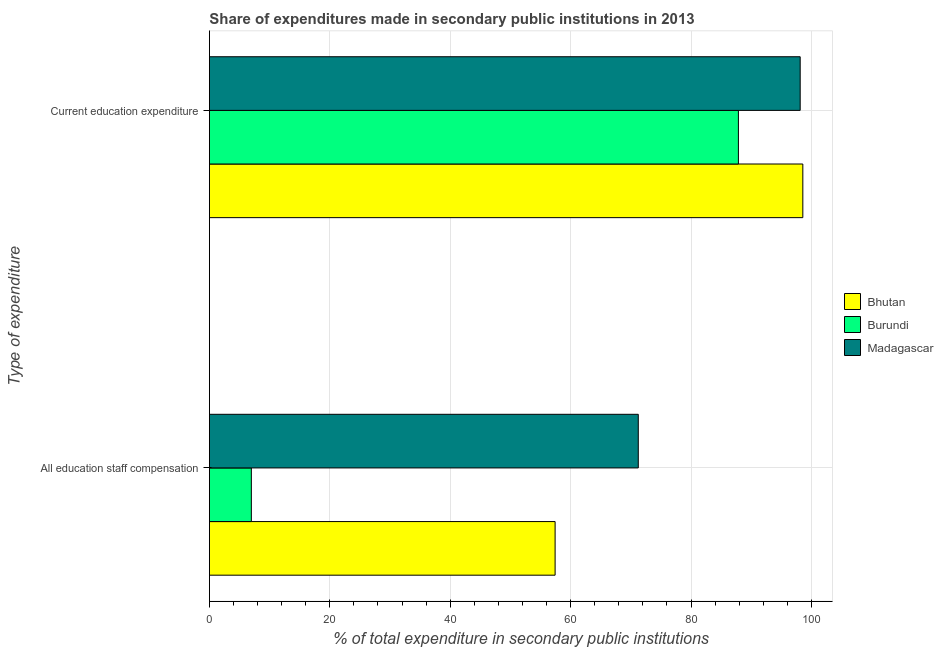How many different coloured bars are there?
Your answer should be very brief. 3. Are the number of bars on each tick of the Y-axis equal?
Give a very brief answer. Yes. What is the label of the 1st group of bars from the top?
Provide a short and direct response. Current education expenditure. What is the expenditure in staff compensation in Burundi?
Provide a short and direct response. 6.97. Across all countries, what is the maximum expenditure in staff compensation?
Give a very brief answer. 71.24. Across all countries, what is the minimum expenditure in education?
Provide a short and direct response. 87.87. In which country was the expenditure in staff compensation maximum?
Give a very brief answer. Madagascar. In which country was the expenditure in education minimum?
Your answer should be compact. Burundi. What is the total expenditure in education in the graph?
Your answer should be very brief. 284.59. What is the difference between the expenditure in staff compensation in Bhutan and that in Madagascar?
Your response must be concise. -13.82. What is the difference between the expenditure in education in Bhutan and the expenditure in staff compensation in Burundi?
Make the answer very short. 91.61. What is the average expenditure in staff compensation per country?
Your response must be concise. 45.21. What is the difference between the expenditure in staff compensation and expenditure in education in Madagascar?
Offer a terse response. -26.89. In how many countries, is the expenditure in education greater than 64 %?
Your response must be concise. 3. What is the ratio of the expenditure in staff compensation in Burundi to that in Madagascar?
Make the answer very short. 0.1. What does the 2nd bar from the top in All education staff compensation represents?
Offer a terse response. Burundi. What does the 2nd bar from the bottom in Current education expenditure represents?
Your answer should be compact. Burundi. How many bars are there?
Your answer should be very brief. 6. How many countries are there in the graph?
Keep it short and to the point. 3. What is the difference between two consecutive major ticks on the X-axis?
Your answer should be compact. 20. Does the graph contain any zero values?
Your response must be concise. No. How many legend labels are there?
Your answer should be very brief. 3. What is the title of the graph?
Provide a short and direct response. Share of expenditures made in secondary public institutions in 2013. What is the label or title of the X-axis?
Make the answer very short. % of total expenditure in secondary public institutions. What is the label or title of the Y-axis?
Provide a succinct answer. Type of expenditure. What is the % of total expenditure in secondary public institutions of Bhutan in All education staff compensation?
Give a very brief answer. 57.43. What is the % of total expenditure in secondary public institutions of Burundi in All education staff compensation?
Make the answer very short. 6.97. What is the % of total expenditure in secondary public institutions of Madagascar in All education staff compensation?
Provide a succinct answer. 71.24. What is the % of total expenditure in secondary public institutions of Bhutan in Current education expenditure?
Ensure brevity in your answer.  98.58. What is the % of total expenditure in secondary public institutions in Burundi in Current education expenditure?
Your response must be concise. 87.87. What is the % of total expenditure in secondary public institutions in Madagascar in Current education expenditure?
Your answer should be very brief. 98.14. Across all Type of expenditure, what is the maximum % of total expenditure in secondary public institutions of Bhutan?
Offer a terse response. 98.58. Across all Type of expenditure, what is the maximum % of total expenditure in secondary public institutions in Burundi?
Make the answer very short. 87.87. Across all Type of expenditure, what is the maximum % of total expenditure in secondary public institutions in Madagascar?
Your response must be concise. 98.14. Across all Type of expenditure, what is the minimum % of total expenditure in secondary public institutions in Bhutan?
Provide a short and direct response. 57.43. Across all Type of expenditure, what is the minimum % of total expenditure in secondary public institutions in Burundi?
Provide a succinct answer. 6.97. Across all Type of expenditure, what is the minimum % of total expenditure in secondary public institutions in Madagascar?
Ensure brevity in your answer.  71.24. What is the total % of total expenditure in secondary public institutions in Bhutan in the graph?
Provide a succinct answer. 156. What is the total % of total expenditure in secondary public institutions in Burundi in the graph?
Your response must be concise. 94.84. What is the total % of total expenditure in secondary public institutions in Madagascar in the graph?
Give a very brief answer. 169.38. What is the difference between the % of total expenditure in secondary public institutions in Bhutan in All education staff compensation and that in Current education expenditure?
Keep it short and to the point. -41.15. What is the difference between the % of total expenditure in secondary public institutions of Burundi in All education staff compensation and that in Current education expenditure?
Keep it short and to the point. -80.91. What is the difference between the % of total expenditure in secondary public institutions in Madagascar in All education staff compensation and that in Current education expenditure?
Offer a terse response. -26.89. What is the difference between the % of total expenditure in secondary public institutions of Bhutan in All education staff compensation and the % of total expenditure in secondary public institutions of Burundi in Current education expenditure?
Give a very brief answer. -30.45. What is the difference between the % of total expenditure in secondary public institutions of Bhutan in All education staff compensation and the % of total expenditure in secondary public institutions of Madagascar in Current education expenditure?
Make the answer very short. -40.71. What is the difference between the % of total expenditure in secondary public institutions in Burundi in All education staff compensation and the % of total expenditure in secondary public institutions in Madagascar in Current education expenditure?
Offer a terse response. -91.17. What is the average % of total expenditure in secondary public institutions of Bhutan per Type of expenditure?
Provide a short and direct response. 78. What is the average % of total expenditure in secondary public institutions in Burundi per Type of expenditure?
Ensure brevity in your answer.  47.42. What is the average % of total expenditure in secondary public institutions of Madagascar per Type of expenditure?
Keep it short and to the point. 84.69. What is the difference between the % of total expenditure in secondary public institutions in Bhutan and % of total expenditure in secondary public institutions in Burundi in All education staff compensation?
Provide a succinct answer. 50.46. What is the difference between the % of total expenditure in secondary public institutions of Bhutan and % of total expenditure in secondary public institutions of Madagascar in All education staff compensation?
Your response must be concise. -13.82. What is the difference between the % of total expenditure in secondary public institutions of Burundi and % of total expenditure in secondary public institutions of Madagascar in All education staff compensation?
Offer a very short reply. -64.28. What is the difference between the % of total expenditure in secondary public institutions in Bhutan and % of total expenditure in secondary public institutions in Burundi in Current education expenditure?
Your answer should be very brief. 10.7. What is the difference between the % of total expenditure in secondary public institutions in Bhutan and % of total expenditure in secondary public institutions in Madagascar in Current education expenditure?
Provide a short and direct response. 0.44. What is the difference between the % of total expenditure in secondary public institutions in Burundi and % of total expenditure in secondary public institutions in Madagascar in Current education expenditure?
Your answer should be very brief. -10.26. What is the ratio of the % of total expenditure in secondary public institutions in Bhutan in All education staff compensation to that in Current education expenditure?
Your answer should be compact. 0.58. What is the ratio of the % of total expenditure in secondary public institutions in Burundi in All education staff compensation to that in Current education expenditure?
Your answer should be compact. 0.08. What is the ratio of the % of total expenditure in secondary public institutions in Madagascar in All education staff compensation to that in Current education expenditure?
Offer a terse response. 0.73. What is the difference between the highest and the second highest % of total expenditure in secondary public institutions of Bhutan?
Your response must be concise. 41.15. What is the difference between the highest and the second highest % of total expenditure in secondary public institutions in Burundi?
Ensure brevity in your answer.  80.91. What is the difference between the highest and the second highest % of total expenditure in secondary public institutions of Madagascar?
Ensure brevity in your answer.  26.89. What is the difference between the highest and the lowest % of total expenditure in secondary public institutions of Bhutan?
Keep it short and to the point. 41.15. What is the difference between the highest and the lowest % of total expenditure in secondary public institutions in Burundi?
Provide a short and direct response. 80.91. What is the difference between the highest and the lowest % of total expenditure in secondary public institutions of Madagascar?
Make the answer very short. 26.89. 